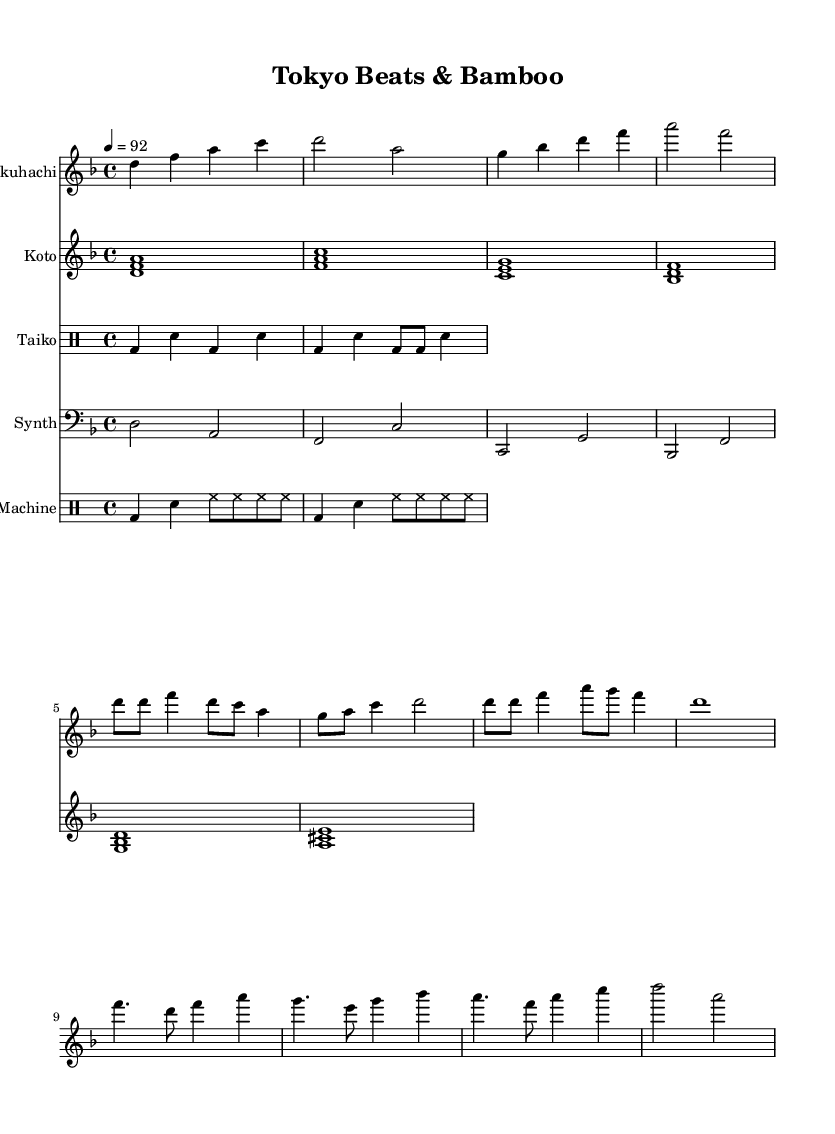What is the key signature of this music? The key signature indicates a D minor tonality, which contains one flat (B flat) and is shown at the beginning of the sheet music.
Answer: D minor What is the time signature of this music? The time signature is indicated in the sheet music as 4/4, meaning there are four beats in each measure and a quarter note receives one beat.
Answer: 4/4 What is the tempo marking for this piece? The tempo marking is indicated as 4 equals 92, which specifies the speed of the music measured in beats per minute.
Answer: 92 Which traditional instrument is represented by the highest pitch in the score? The Shakuhachi is written in the treble clef and generally plays higher pitches than the Koto, which is also written in the treble clef but is notable for its lower range.
Answer: Shakuhachi How many drum sections are present in the score? There are two drum sections specified, one for Taiko and another for the Drum Machine, each marked distinctly in their respective staff.
Answer: Two What type of traditional music influences are evident in this piece? The piece incorporates the sounds and tonalities of Japanese traditional music, particularly through the use of instruments like the Shakuhachi and Koto, combined with modern electronic elements such as Synth and Drum Machine, reflecting a fusion genre.
Answer: Japanese traditional music What rhythmic element is primarily featured in the drum sections? The principal rhythmic element in both the Taiko and Drum Machine sections comprises kick and snare patterns, which provide a driving beat characteristic of both traditional and contemporary styles.
Answer: Kick and snare 